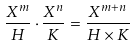Convert formula to latex. <formula><loc_0><loc_0><loc_500><loc_500>\frac { X ^ { m } } { H } \cdot \frac { X ^ { n } } { K } = \frac { X ^ { m + n } } { H \times K }</formula> 